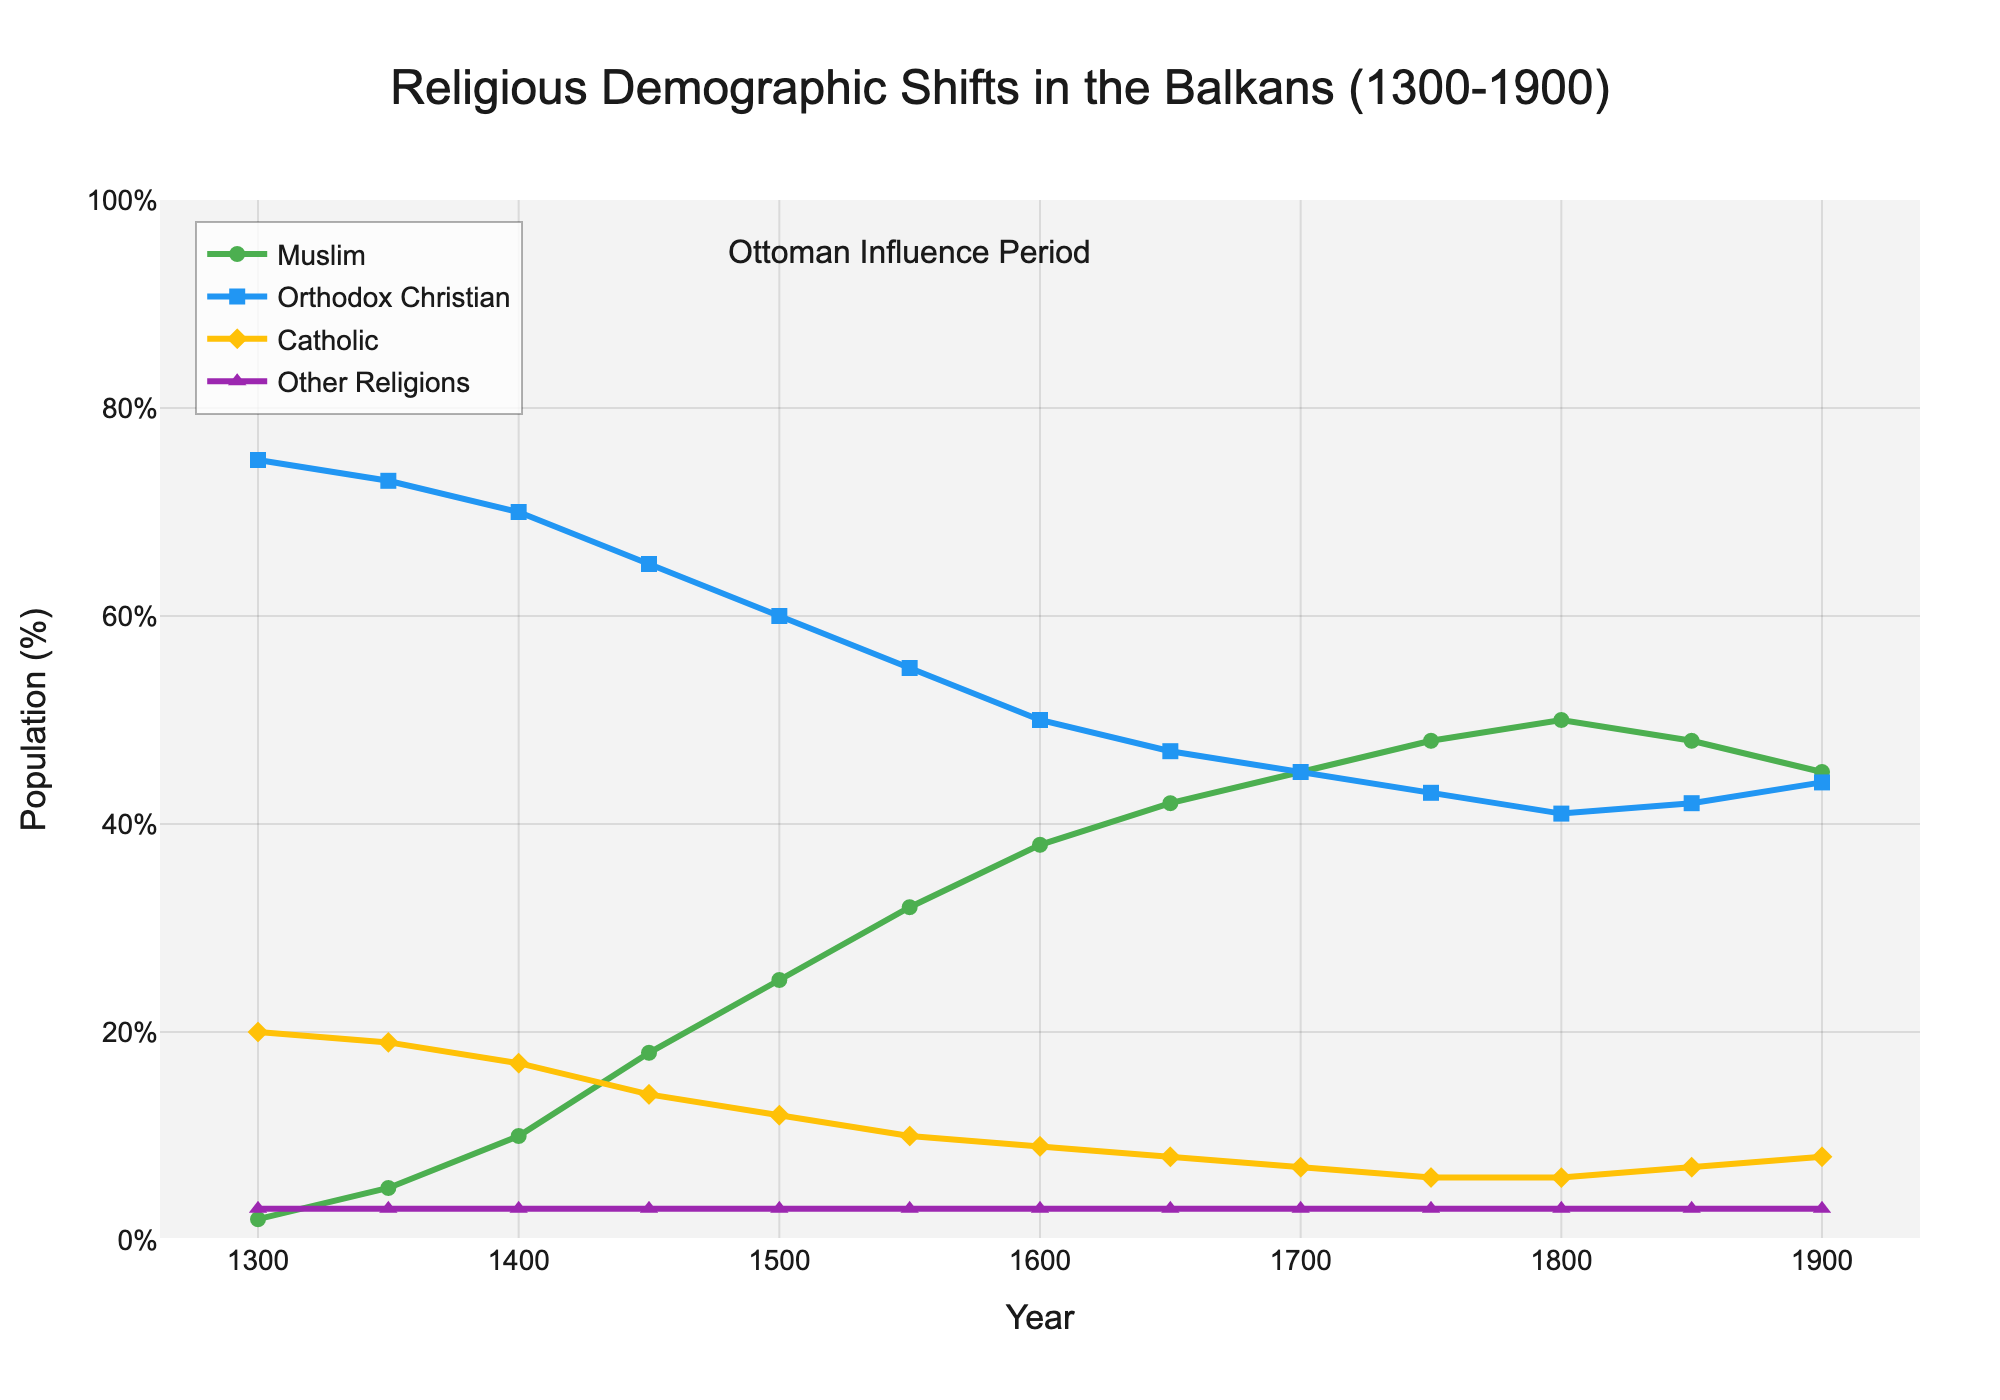What is the overall trend of the Muslim Population (%) between 1300 and 1900? The Muslim Population (%) starts at 2% in 1300 and increases steadily until it peaks at 50% in 1800. After 1800, it slightly decreases to 45% by 1900.
Answer: Increase until 1800, then slight decrease When did the Orthodox Christian Population (%) first become less than 50%? In 1600, the Orthodox Christian Population (%) was exactly 50%, and in 1650 it decreased to 47%, making 1600 the turning point.
Answer: 1600 Which year had the maximum percentage of Catholic Population (%) and what was it? The maximum percentage of Catholic Population (%) was in 1300, which was 20%.
Answer: 1300, 20% Did the percentage of "Other Religions" change over time, and if so, how? The percentage of "Other Religions" remained constant at 3% throughout the entire period from 1300 to 1900.
Answer: No change, constant at 3% What was the percentage difference between Orthodox Christian Population (%) and Muslim Population (%) in 1500? The Orthodox Christian Population (%) in 1500 was 60%, and the Muslim Population (%) was 25%. The difference is 60% - 25% = 35%.
Answer: 35% What is the median percentage of Orthodox Christian Population (%) over the entire period shown? The values are: 75, 73, 70, 65, 60, 55, 50, 47, 45, 43, 41, 42, 44. The median is the middle value when ordered, which is 50%.
Answer: 50% Which religion had the smallest percentage of population change from 1300 to 1900? "Other Religions" maintained a constant 3% from 1300 to 1900, experiencing no change. All other religions experienced significant changes.
Answer: Other Religions How does the trend of Catholic Population (%) compare to Orthodox Christian Population (%) between 1500 and 1800? Both populations show a declining trend during this period. Orthodox Christian Population (%) decreased from 60% to 41%, while the Catholic Population (%) decreased from 12% to 6%.
Answer: Both declined 